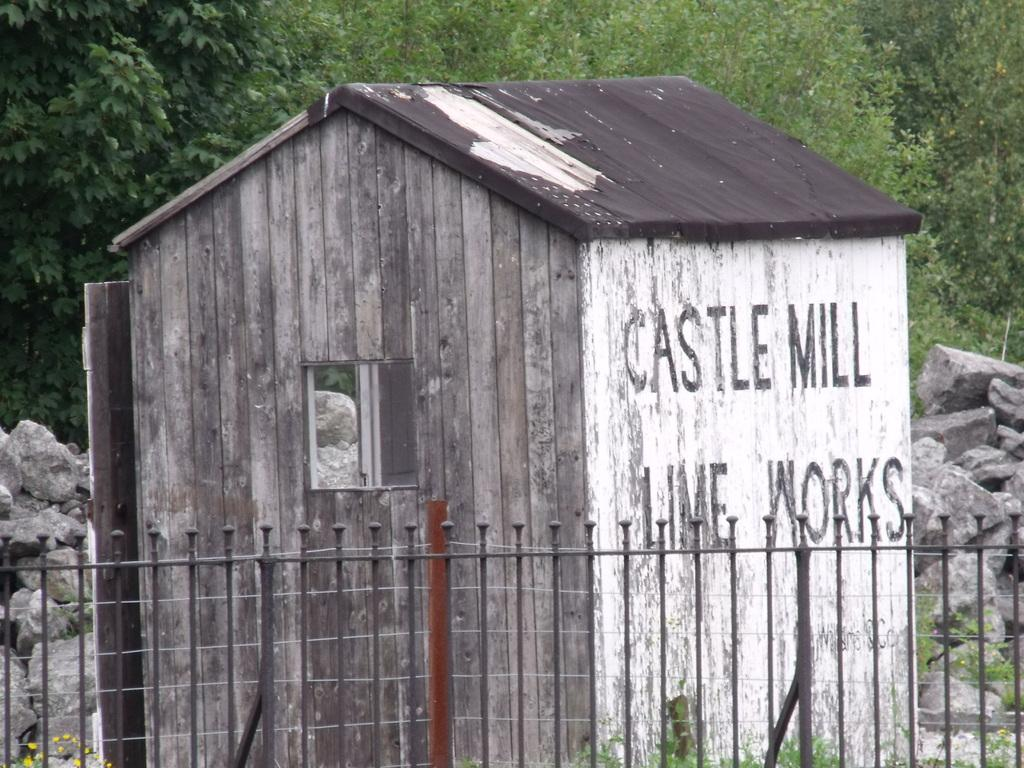<image>
Provide a brief description of the given image. a little barn that says 'castle mill lime works' on the outside of it 